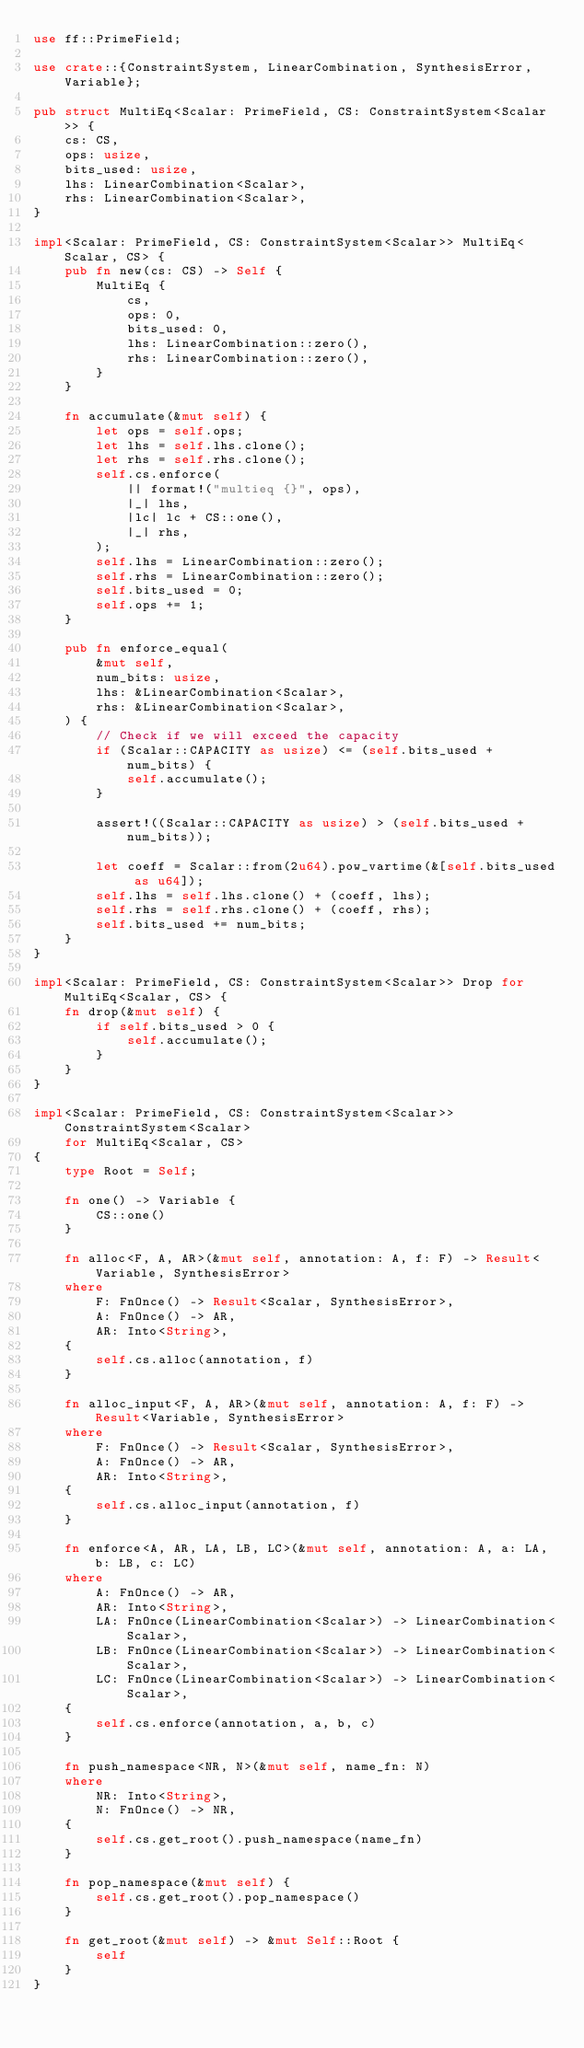Convert code to text. <code><loc_0><loc_0><loc_500><loc_500><_Rust_>use ff::PrimeField;

use crate::{ConstraintSystem, LinearCombination, SynthesisError, Variable};

pub struct MultiEq<Scalar: PrimeField, CS: ConstraintSystem<Scalar>> {
    cs: CS,
    ops: usize,
    bits_used: usize,
    lhs: LinearCombination<Scalar>,
    rhs: LinearCombination<Scalar>,
}

impl<Scalar: PrimeField, CS: ConstraintSystem<Scalar>> MultiEq<Scalar, CS> {
    pub fn new(cs: CS) -> Self {
        MultiEq {
            cs,
            ops: 0,
            bits_used: 0,
            lhs: LinearCombination::zero(),
            rhs: LinearCombination::zero(),
        }
    }

    fn accumulate(&mut self) {
        let ops = self.ops;
        let lhs = self.lhs.clone();
        let rhs = self.rhs.clone();
        self.cs.enforce(
            || format!("multieq {}", ops),
            |_| lhs,
            |lc| lc + CS::one(),
            |_| rhs,
        );
        self.lhs = LinearCombination::zero();
        self.rhs = LinearCombination::zero();
        self.bits_used = 0;
        self.ops += 1;
    }

    pub fn enforce_equal(
        &mut self,
        num_bits: usize,
        lhs: &LinearCombination<Scalar>,
        rhs: &LinearCombination<Scalar>,
    ) {
        // Check if we will exceed the capacity
        if (Scalar::CAPACITY as usize) <= (self.bits_used + num_bits) {
            self.accumulate();
        }

        assert!((Scalar::CAPACITY as usize) > (self.bits_used + num_bits));

        let coeff = Scalar::from(2u64).pow_vartime(&[self.bits_used as u64]);
        self.lhs = self.lhs.clone() + (coeff, lhs);
        self.rhs = self.rhs.clone() + (coeff, rhs);
        self.bits_used += num_bits;
    }
}

impl<Scalar: PrimeField, CS: ConstraintSystem<Scalar>> Drop for MultiEq<Scalar, CS> {
    fn drop(&mut self) {
        if self.bits_used > 0 {
            self.accumulate();
        }
    }
}

impl<Scalar: PrimeField, CS: ConstraintSystem<Scalar>> ConstraintSystem<Scalar>
    for MultiEq<Scalar, CS>
{
    type Root = Self;

    fn one() -> Variable {
        CS::one()
    }

    fn alloc<F, A, AR>(&mut self, annotation: A, f: F) -> Result<Variable, SynthesisError>
    where
        F: FnOnce() -> Result<Scalar, SynthesisError>,
        A: FnOnce() -> AR,
        AR: Into<String>,
    {
        self.cs.alloc(annotation, f)
    }

    fn alloc_input<F, A, AR>(&mut self, annotation: A, f: F) -> Result<Variable, SynthesisError>
    where
        F: FnOnce() -> Result<Scalar, SynthesisError>,
        A: FnOnce() -> AR,
        AR: Into<String>,
    {
        self.cs.alloc_input(annotation, f)
    }

    fn enforce<A, AR, LA, LB, LC>(&mut self, annotation: A, a: LA, b: LB, c: LC)
    where
        A: FnOnce() -> AR,
        AR: Into<String>,
        LA: FnOnce(LinearCombination<Scalar>) -> LinearCombination<Scalar>,
        LB: FnOnce(LinearCombination<Scalar>) -> LinearCombination<Scalar>,
        LC: FnOnce(LinearCombination<Scalar>) -> LinearCombination<Scalar>,
    {
        self.cs.enforce(annotation, a, b, c)
    }

    fn push_namespace<NR, N>(&mut self, name_fn: N)
    where
        NR: Into<String>,
        N: FnOnce() -> NR,
    {
        self.cs.get_root().push_namespace(name_fn)
    }

    fn pop_namespace(&mut self) {
        self.cs.get_root().pop_namespace()
    }

    fn get_root(&mut self) -> &mut Self::Root {
        self
    }
}
</code> 